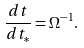<formula> <loc_0><loc_0><loc_500><loc_500>\frac { d t } { d t _ { * } } = \Omega ^ { - 1 } .</formula> 